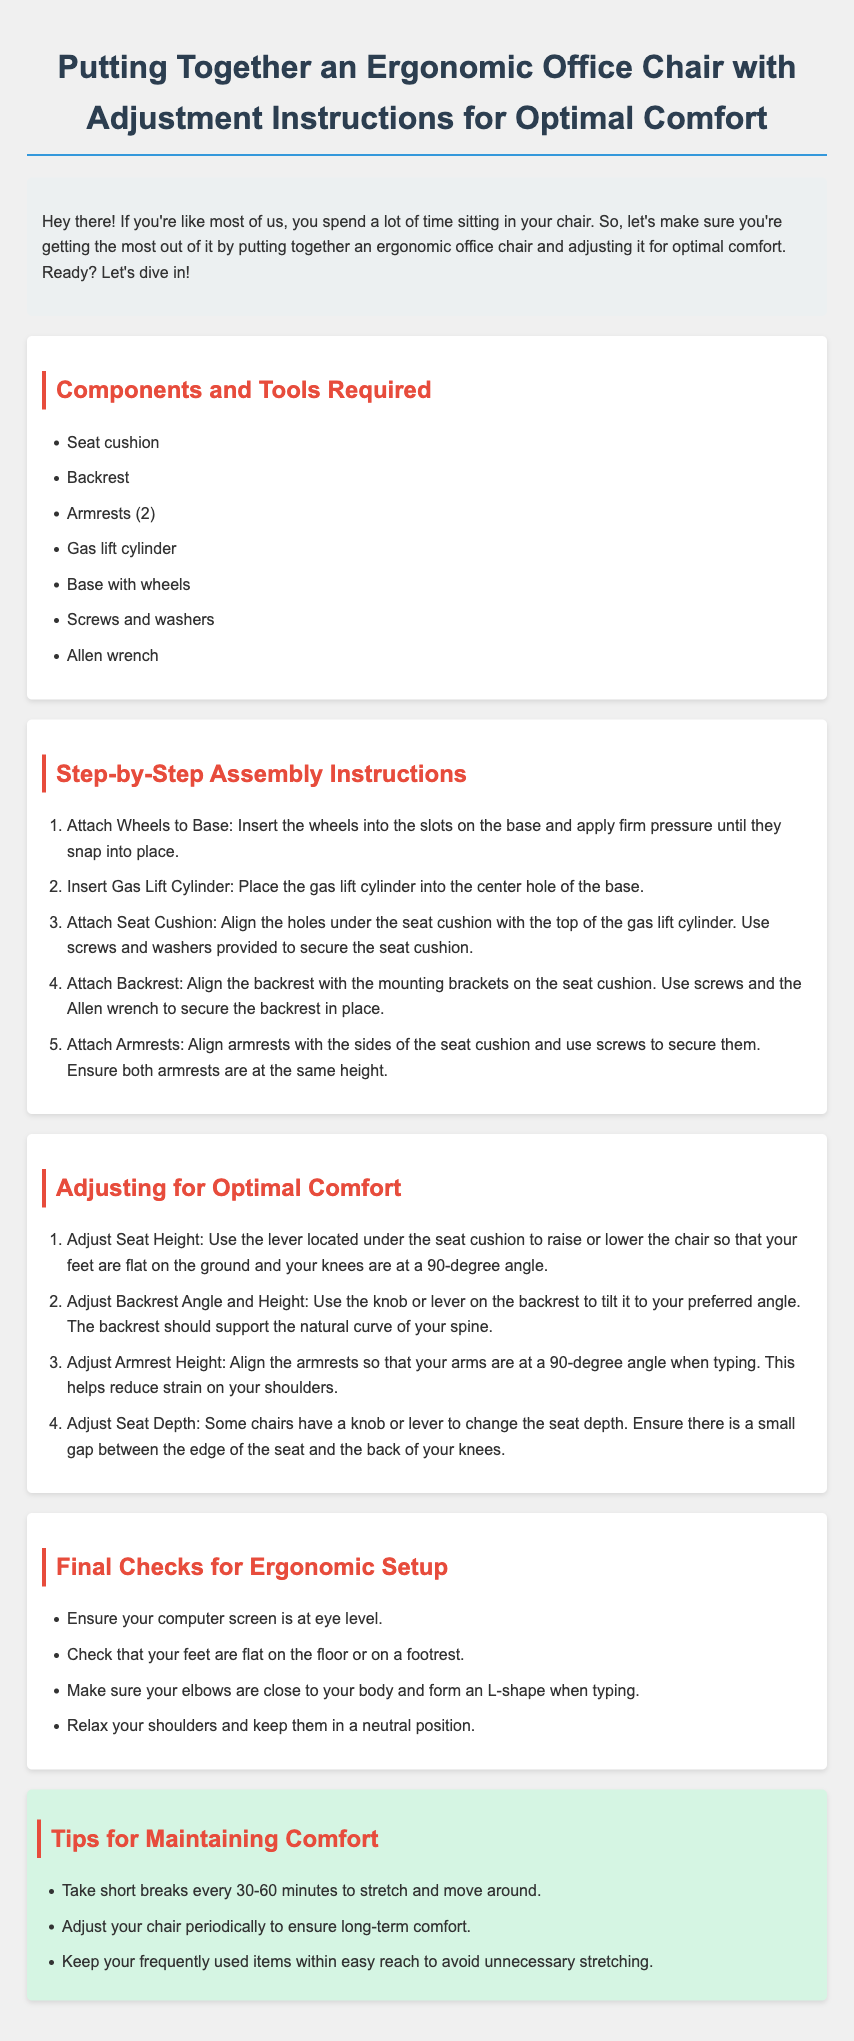What are the components required for assembly? The document lists the components needed for assembly which include seat cushion, backrest, armrests, gas lift cylinder, base with wheels, screws and washers, and Allen wrench.
Answer: Seat cushion, backrest, armrests, gas lift cylinder, base with wheels, screws and washers, Allen wrench How many armrests are included? The document specifies the number of armrests to be used in assembly which is two.
Answer: 2 What tool is used to secure the backrest? The document mentions that screws and the Allen wrench are used to secure the backrest in place.
Answer: Allen wrench What adjustment helps reduce strain on shoulders? The document indicates that adjusting the armrest height helps reduce strain on your shoulders.
Answer: Armrest height How often should you take breaks? The document recommends taking short breaks every 30-60 minutes to stretch and move around.
Answer: Every 30-60 minutes What should your feet be when adjusting seat height? The document advises that your feet should be flat on the ground when adjusting the seat height.
Answer: Flat on the ground What is the purpose of the tips section? The tips section provides additional advice for maintaining comfort while using the chair over time.
Answer: Maintain comfort What should the computer screen be at? The document states that the computer screen should be at eye level for ergonomic setup.
Answer: Eye level How should your elbows be positioned when typing? The document specifies that your elbows should be close to your body and form an L-shape when typing.
Answer: L-shape 